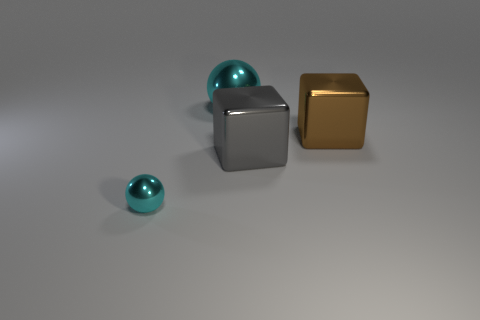Add 2 small things. How many objects exist? 6 Subtract 1 brown blocks. How many objects are left? 3 Subtract all gray metal objects. Subtract all red blocks. How many objects are left? 3 Add 3 large cyan metallic balls. How many large cyan metallic balls are left? 4 Add 3 metal blocks. How many metal blocks exist? 5 